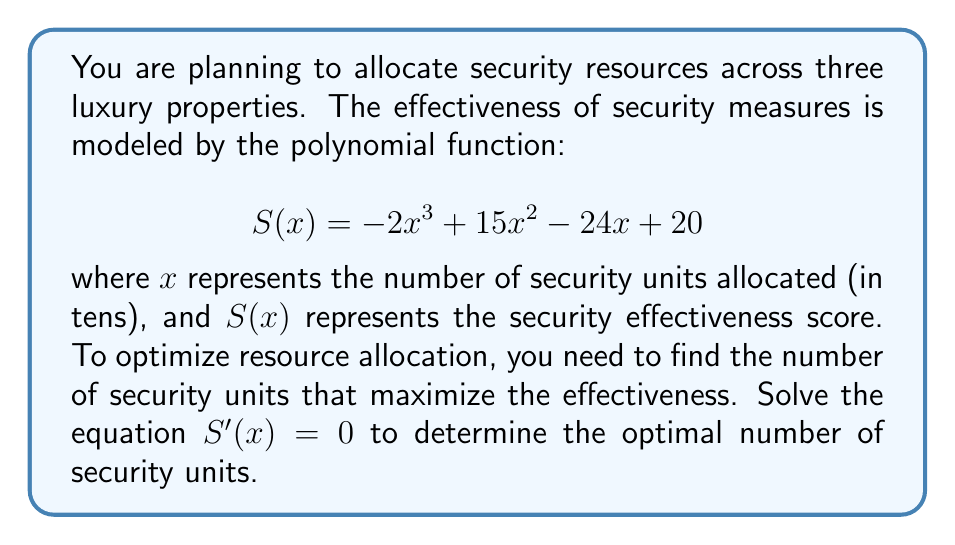Could you help me with this problem? To find the maximum value of the security effectiveness function, we need to find where its derivative equals zero. This will give us the critical points.

1) First, let's find the derivative of $S(x)$:
   $$S'(x) = -6x^2 + 30x - 24$$

2) Now, we set $S'(x) = 0$ and solve for x:
   $$-6x^2 + 30x - 24 = 0$$

3) This is a quadratic equation. We can solve it using the quadratic formula:
   $$x = \frac{-b \pm \sqrt{b^2 - 4ac}}{2a}$$
   where $a = -6$, $b = 30$, and $c = -24$

4) Substituting these values:
   $$x = \frac{-30 \pm \sqrt{30^2 - 4(-6)(-24)}}{2(-6)}$$
   $$= \frac{-30 \pm \sqrt{900 - 576}}{-12}$$
   $$= \frac{-30 \pm \sqrt{324}}{-12}$$
   $$= \frac{-30 \pm 18}{-12}$$

5) This gives us two solutions:
   $$x = \frac{-30 + 18}{-12} = 1$$ or $$x = \frac{-30 - 18}{-12} = 4$$

6) Since $x$ represents the number of security units in tens, these solutions correspond to 10 and 40 units respectively.

7) To determine which of these is the maximum (rather than the minimum), we can check the second derivative:
   $$S''(x) = -12x + 30$$
   At $x = 1$: $S''(1) = 18 > 0$, indicating a local minimum.
   At $x = 4$: $S''(4) = -18 < 0$, indicating a local maximum.

Therefore, the security effectiveness is maximized when 40 units are allocated.
Answer: The optimal number of security units to allocate is 40, corresponding to $x = 4$ in the original equation where $x$ was in tens of units. 